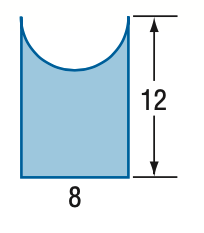Question: Find the area of the figure. Round to the nearest tenth if necessary.
Choices:
A. 45.7
B. 70.9
C. 83.4
D. 96
Answer with the letter. Answer: B 